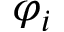Convert formula to latex. <formula><loc_0><loc_0><loc_500><loc_500>\varphi _ { i }</formula> 